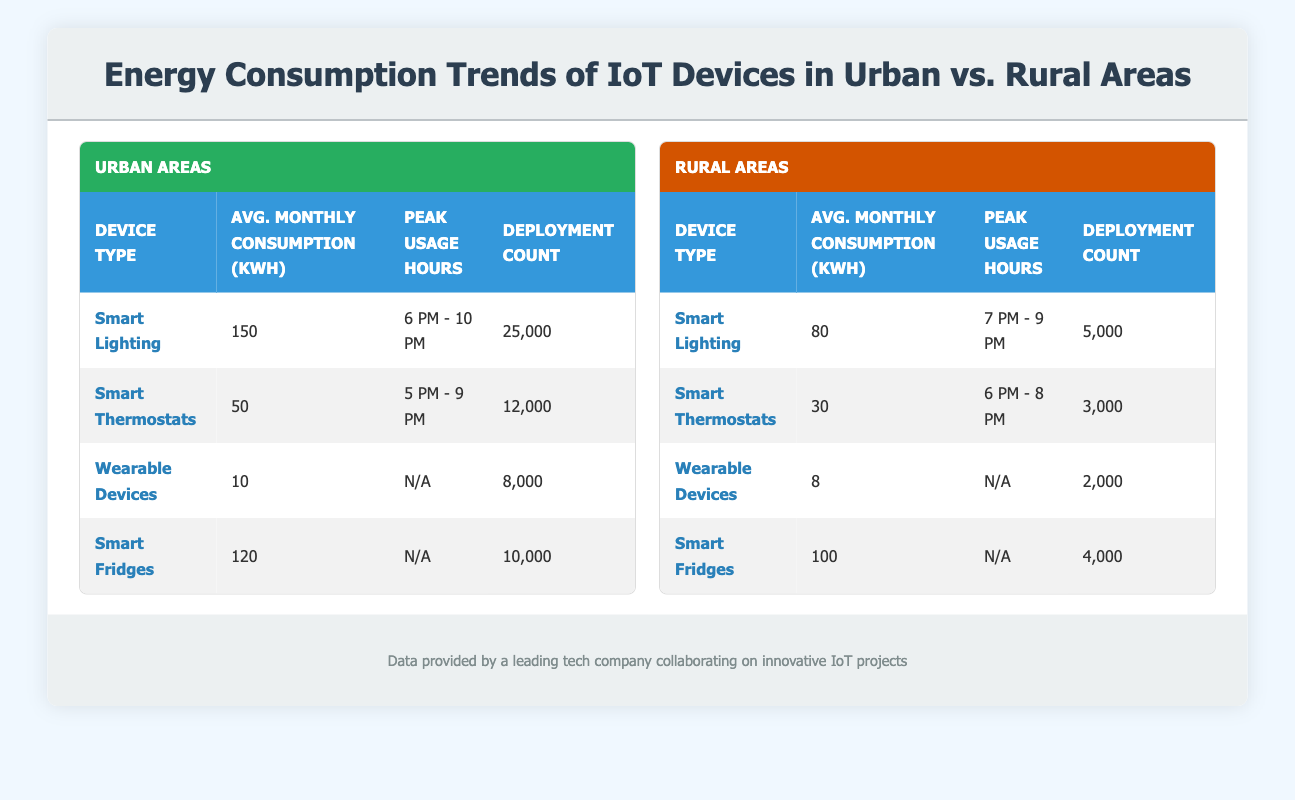What is the average monthly energy consumption for Smart Lighting devices in urban areas? The average monthly energy consumption for Smart Lighting in urban areas is listed in the table as 150 kWh.
Answer: 150 How many Smart Thermostats are deployed in rural areas? The deployment count for Smart Thermostats in rural areas is clearly stated in the table as 3000.
Answer: 3000 Is the average monthly energy consumption of Wearable Devices in urban areas greater than in rural areas? The average monthly consumption for Wearable Devices in urban areas is 10 kWh, while in rural areas it is 8 kWh. Since 10 is greater than 8, the statement is true.
Answer: Yes What is the peak usage hour for Smart Fridges in urban areas? The peak usage hours for Smart Fridges in urban areas is marked as N/A (not applicable) in the table.
Answer: N/A Calculate the total deployment count of Smart Lighting devices in both urban and rural areas. The deployment count for Smart Lighting in urban areas is 25,000 and in rural areas is 5,000. Adding these together gives 25,000 + 5,000 = 30,000.
Answer: 30,000 Do Smart Thermostats in urban areas consume more energy on average than Smart Fridges in rural areas? The average monthly consumption for Smart Thermostats in urban areas is 50 kWh. For Smart Fridges in rural areas, it is 100 kWh. Since 50 is less than 100, the statement is false.
Answer: No What is the difference in average monthly energy consumption between Smart Lighting in urban areas and Smart Lighting in rural areas? The average consumption for Smart Lighting in urban areas is 150 kWh, while in rural areas it is 80 kWh. The difference is 150 - 80 = 70 kWh.
Answer: 70 Which type of device has the highest deployment count in urban areas? The highest deployment count in urban areas is for Smart Lighting, with a count of 25,000 as indicated in the table.
Answer: Smart Lighting What are the peak usage hours for Smart Thermostats in urban areas? According to the table, the peak usage hours for Smart Thermostats in urban areas are listed as 5 PM - 9 PM.
Answer: 5 PM - 9 PM What is the total average monthly energy consumption of all wearable devices across both urban and rural areas? In urban areas, the average monthly consumption is 10 kWh for Wearable Devices, and in rural areas, it is 8 kWh. Adding both gives 10 + 8 = 18 kWh.
Answer: 18 